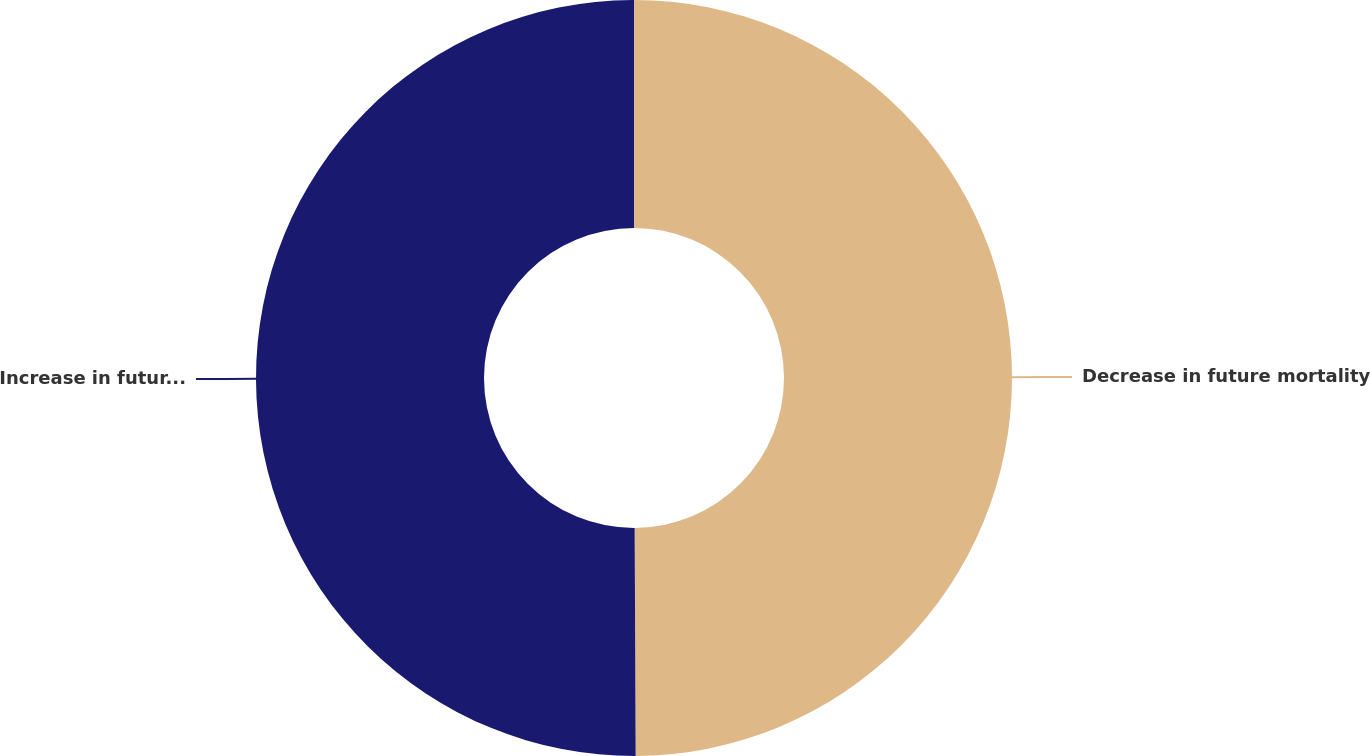Convert chart to OTSL. <chart><loc_0><loc_0><loc_500><loc_500><pie_chart><fcel>Decrease in future mortality<fcel>Increase in future mortality<nl><fcel>49.93%<fcel>50.07%<nl></chart> 